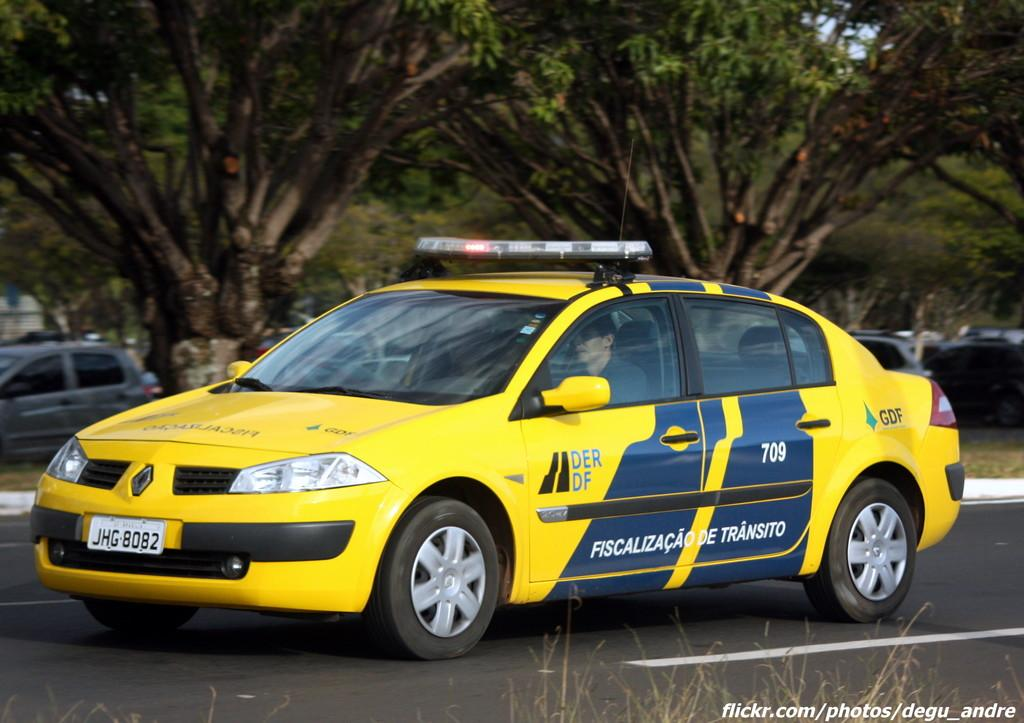<image>
Create a compact narrative representing the image presented. A yellow car with lights on top and a tag that says JHG 8082. 